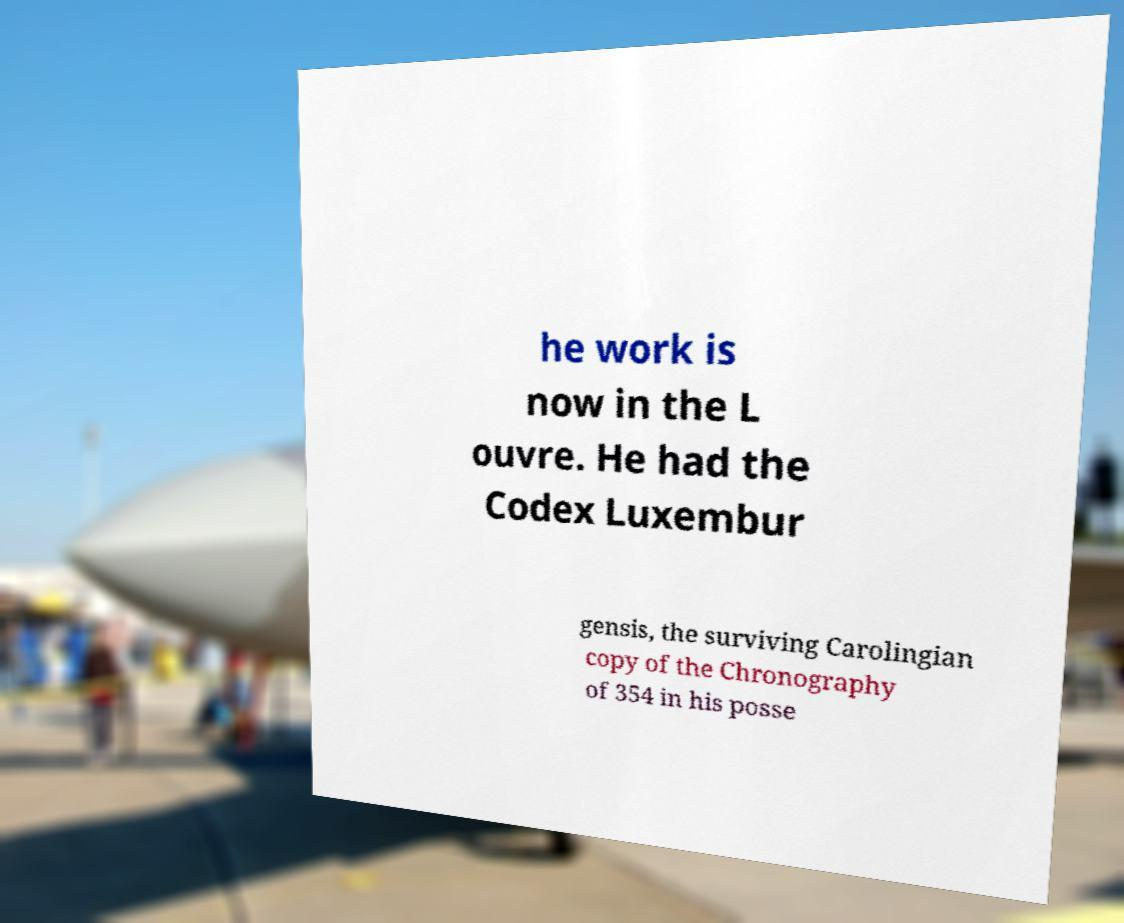What messages or text are displayed in this image? I need them in a readable, typed format. he work is now in the L ouvre. He had the Codex Luxembur gensis, the surviving Carolingian copy of the Chronography of 354 in his posse 